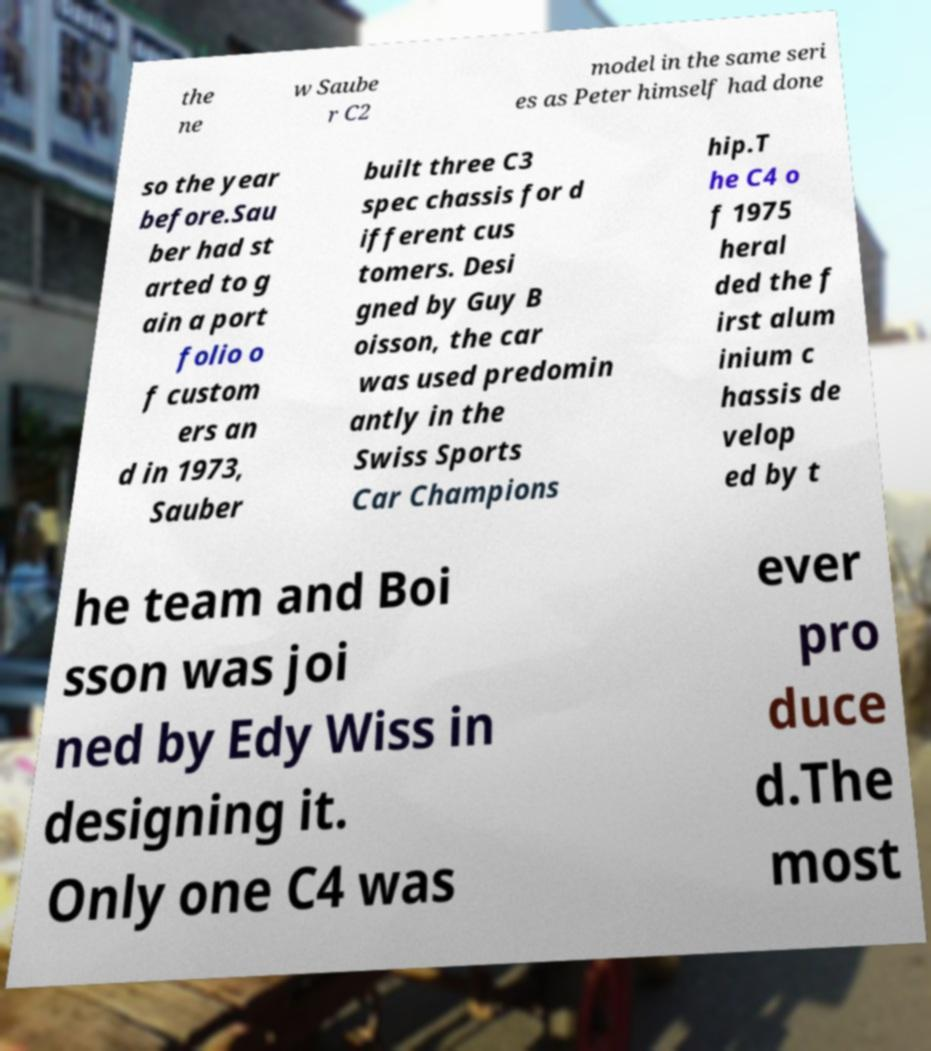Can you read and provide the text displayed in the image?This photo seems to have some interesting text. Can you extract and type it out for me? the ne w Saube r C2 model in the same seri es as Peter himself had done so the year before.Sau ber had st arted to g ain a port folio o f custom ers an d in 1973, Sauber built three C3 spec chassis for d ifferent cus tomers. Desi gned by Guy B oisson, the car was used predomin antly in the Swiss Sports Car Champions hip.T he C4 o f 1975 heral ded the f irst alum inium c hassis de velop ed by t he team and Boi sson was joi ned by Edy Wiss in designing it. Only one C4 was ever pro duce d.The most 